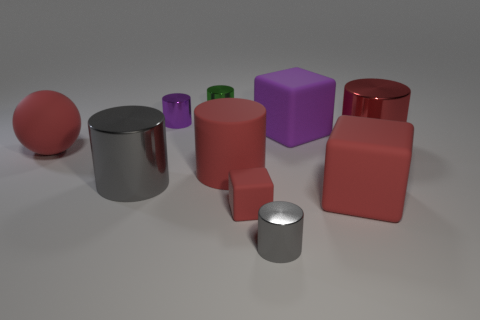Do the tiny shiny thing that is in front of the large red metal cylinder and the small purple object have the same shape?
Offer a very short reply. Yes. Is the number of big purple matte blocks less than the number of large shiny balls?
Make the answer very short. No. How many big blocks have the same color as the large matte cylinder?
Provide a short and direct response. 1. There is a small thing that is the same color as the matte cylinder; what is its material?
Offer a very short reply. Rubber. There is a small matte cube; does it have the same color as the tiny cylinder that is in front of the tiny matte thing?
Offer a very short reply. No. Are there more big shiny objects than big red spheres?
Make the answer very short. Yes. The purple metallic thing that is the same shape as the tiny green thing is what size?
Give a very brief answer. Small. Is the material of the purple cylinder the same as the red cylinder that is to the right of the purple rubber block?
Your response must be concise. Yes. What number of objects are large purple matte cylinders or tiny shiny cylinders?
Offer a terse response. 3. Is the size of the red cylinder in front of the red shiny cylinder the same as the gray metallic thing to the left of the purple metal object?
Ensure brevity in your answer.  Yes. 